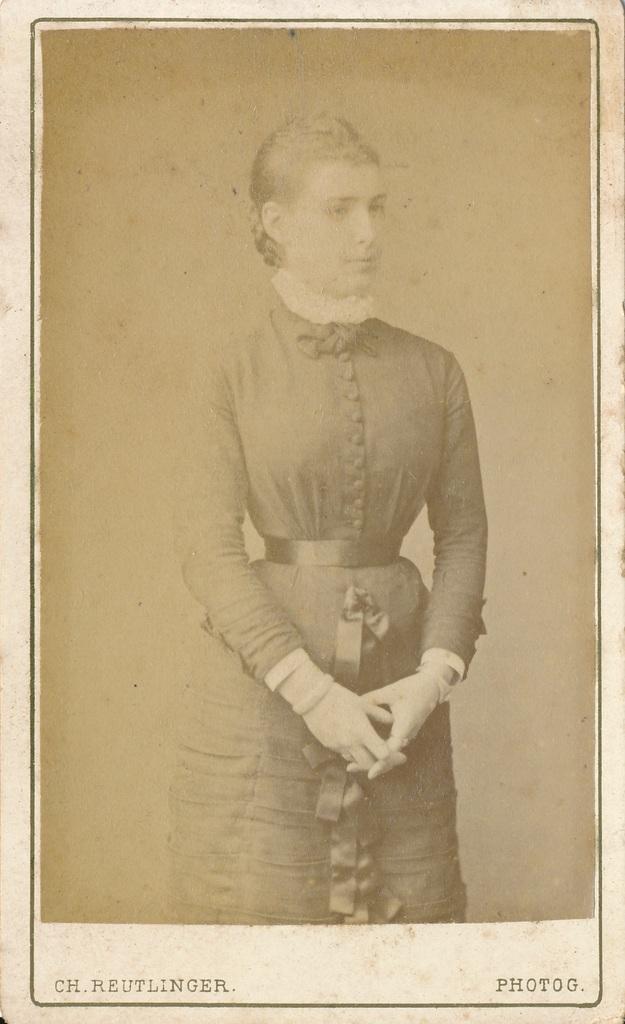Please provide a concise description of this image. This is a picture of a photo, where there is a person standing , and there are some words on the photo. 